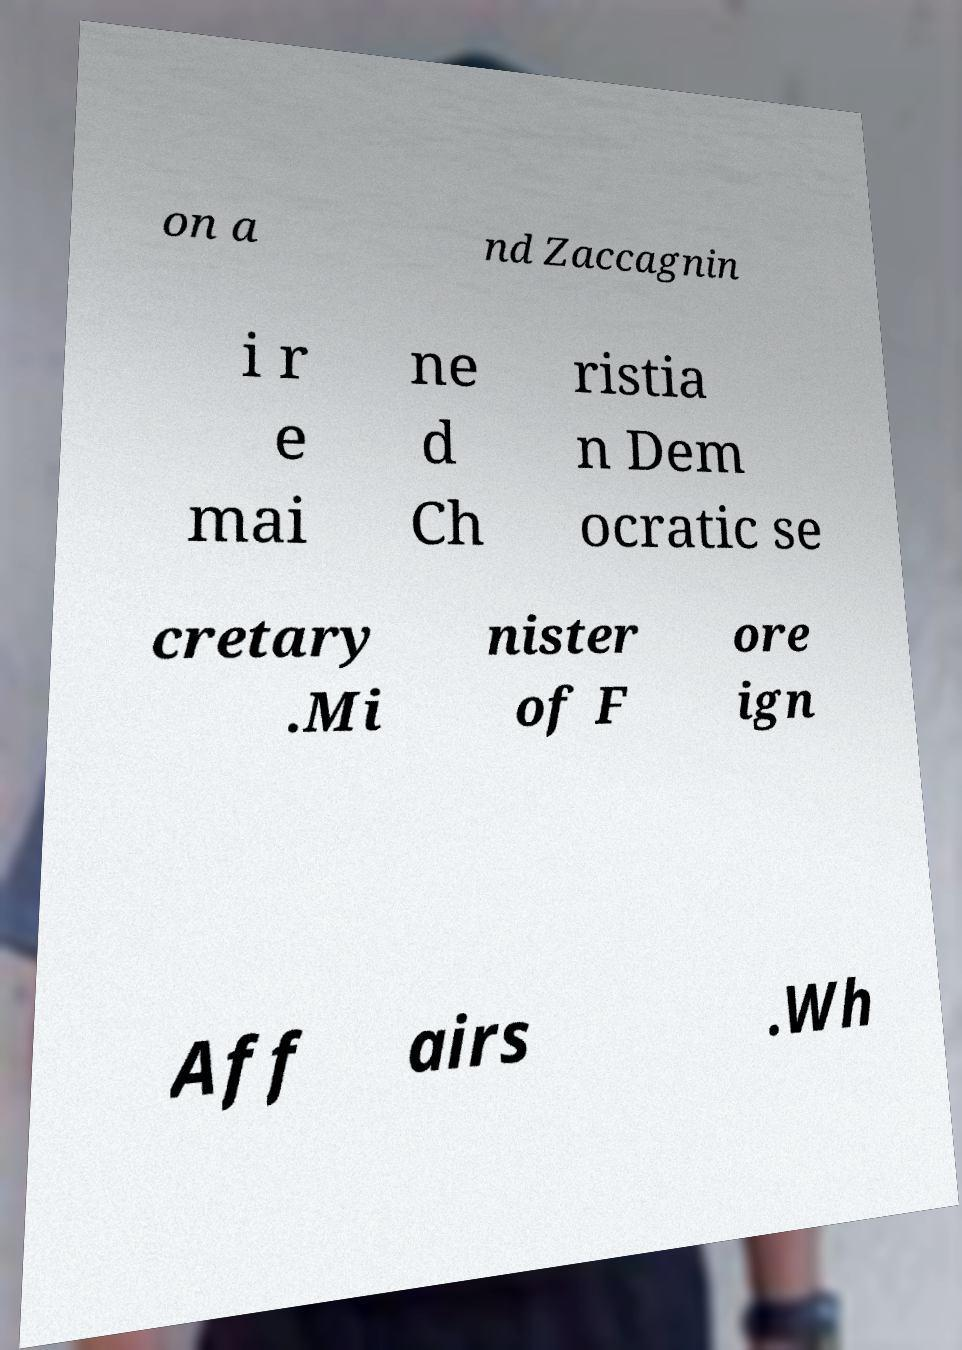Can you read and provide the text displayed in the image?This photo seems to have some interesting text. Can you extract and type it out for me? on a nd Zaccagnin i r e mai ne d Ch ristia n Dem ocratic se cretary .Mi nister of F ore ign Aff airs .Wh 